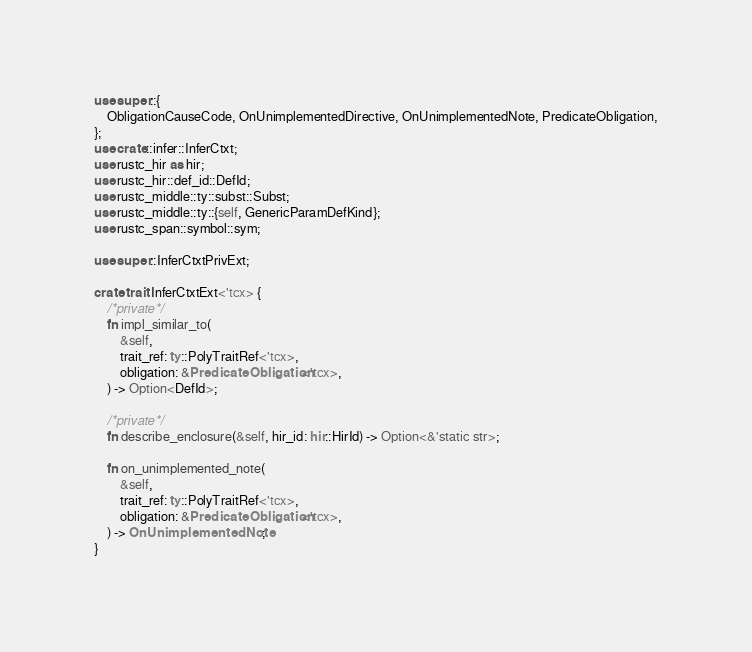Convert code to text. <code><loc_0><loc_0><loc_500><loc_500><_Rust_>use super::{
    ObligationCauseCode, OnUnimplementedDirective, OnUnimplementedNote, PredicateObligation,
};
use crate::infer::InferCtxt;
use rustc_hir as hir;
use rustc_hir::def_id::DefId;
use rustc_middle::ty::subst::Subst;
use rustc_middle::ty::{self, GenericParamDefKind};
use rustc_span::symbol::sym;

use super::InferCtxtPrivExt;

crate trait InferCtxtExt<'tcx> {
    /*private*/
    fn impl_similar_to(
        &self,
        trait_ref: ty::PolyTraitRef<'tcx>,
        obligation: &PredicateObligation<'tcx>,
    ) -> Option<DefId>;

    /*private*/
    fn describe_enclosure(&self, hir_id: hir::HirId) -> Option<&'static str>;

    fn on_unimplemented_note(
        &self,
        trait_ref: ty::PolyTraitRef<'tcx>,
        obligation: &PredicateObligation<'tcx>,
    ) -> OnUnimplementedNote;
}
</code> 